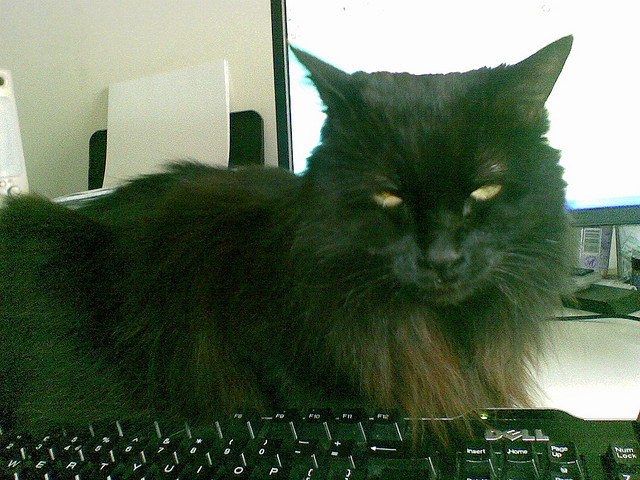Please identify all text content in this image. Page 7 0 O P Lock Num Up Home DELL O I U O Y T 5 A R E W 3 2 